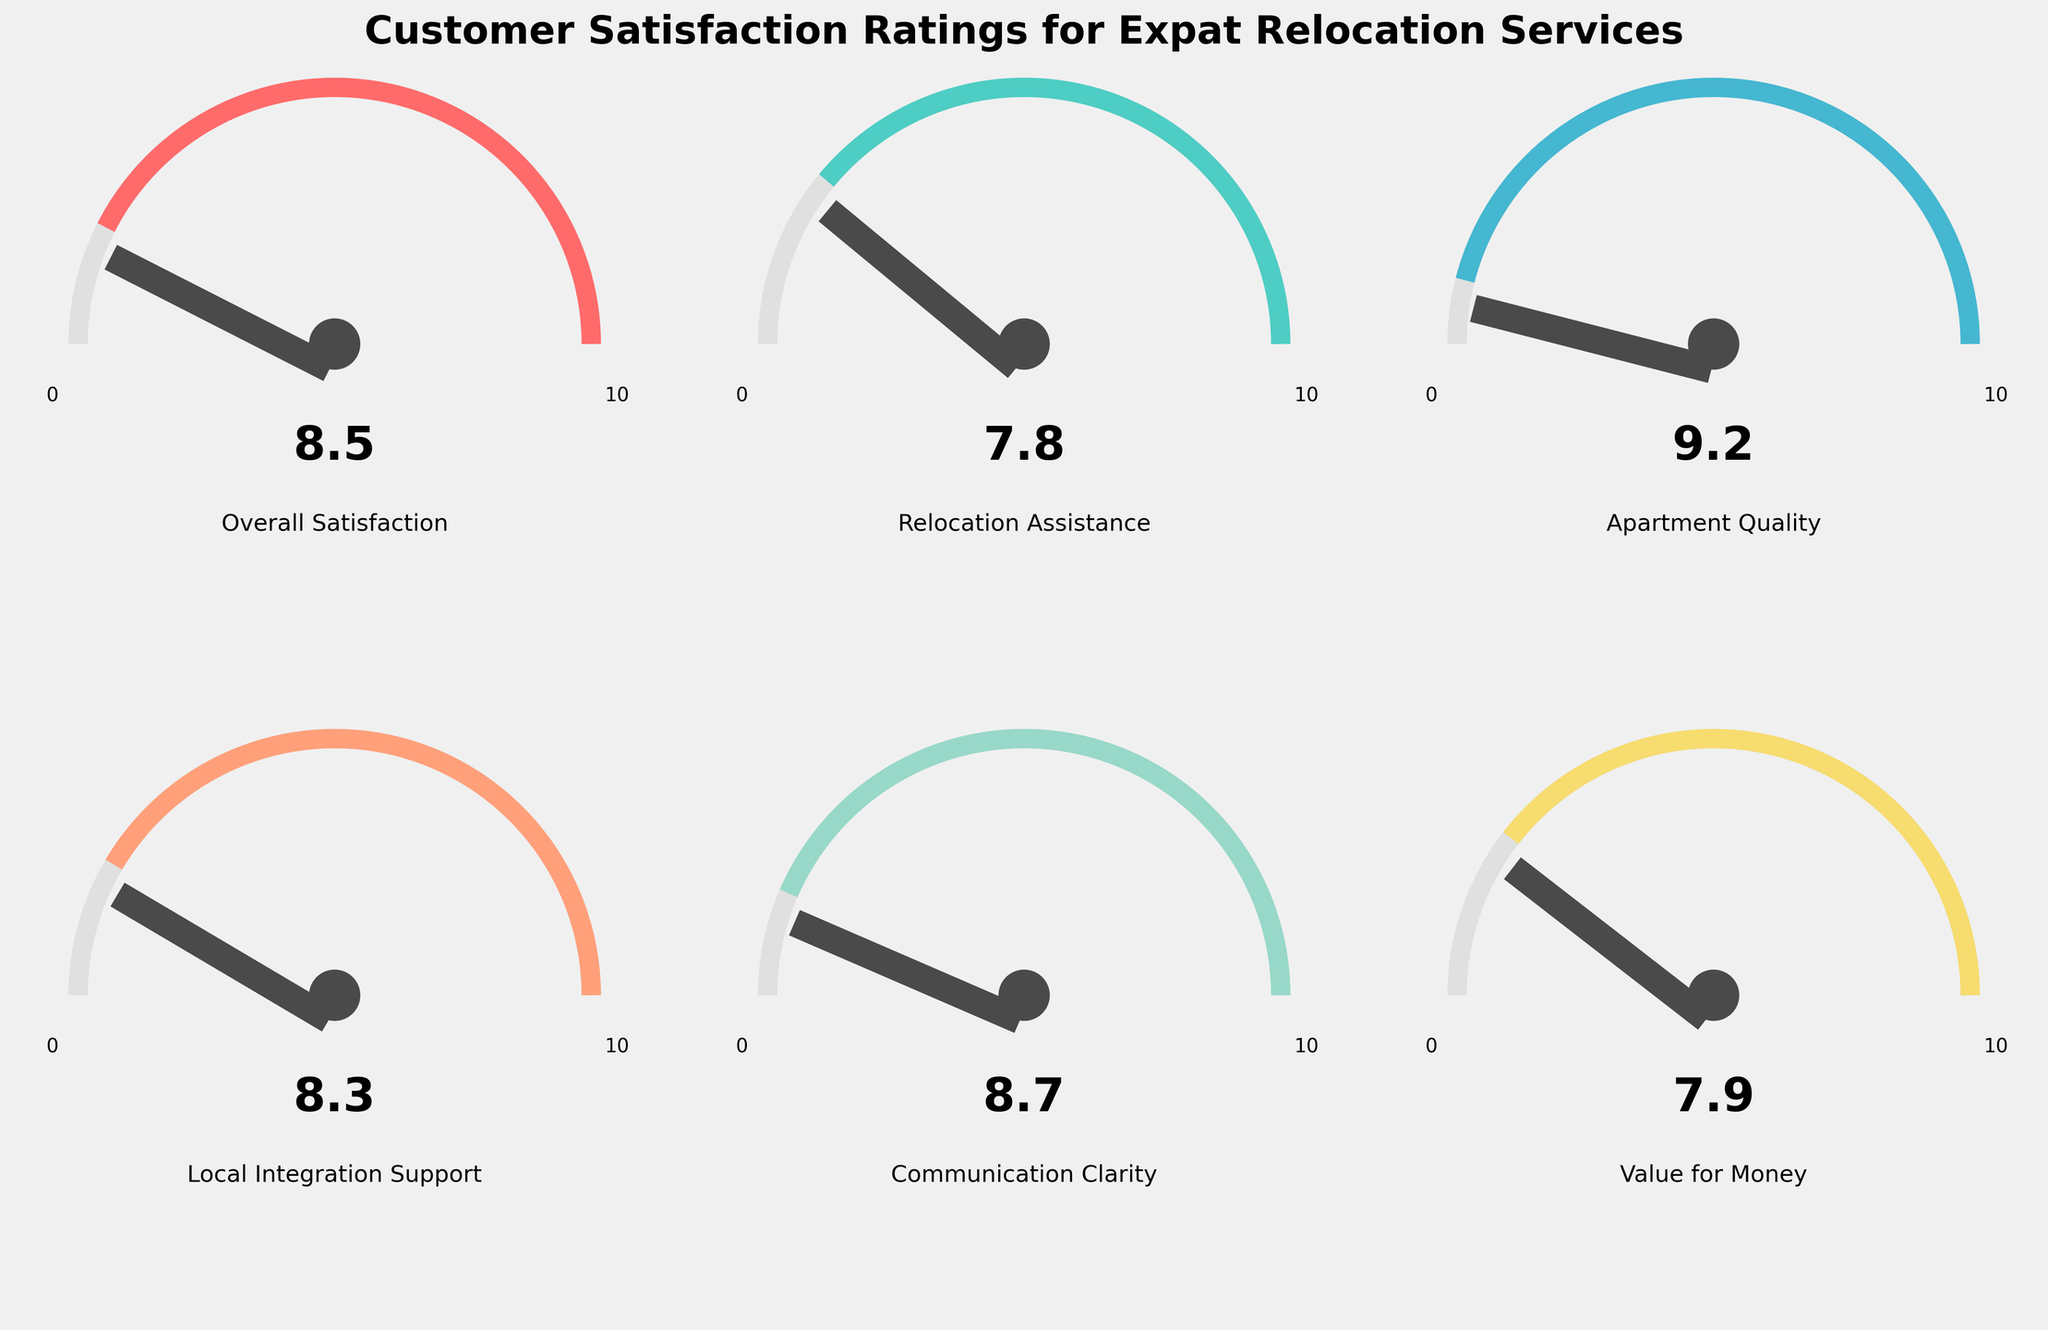What is the title of the chart? The title of the chart is located at the top of the figure, usually in a larger and bolder font. In this case, it reads "Customer Satisfaction Ratings for Expat Relocation Services".
Answer: Customer Satisfaction Ratings for Expat Relocation Services How many categories are shown in the figure? The figure consists of multiple gauges, each representing a different category. By counting these gauges, we can determine the total number of categories.
Answer: Six Which category has the highest satisfaction rating? To determine the highest rating, we compare the values indicated on each gauge. The one with the highest value is "Apartment Quality" with a value of 9.2.
Answer: Apartment Quality Compare the "Relocation Assistance" and "Value for Money" ratings. Which one is higher and by how much? "Relocation Assistance" has a rating of 7.8, and "Value for Money" has a rating of 7.9. By subtracting the two values, we see that "Value for Money" is higher by 0.1.
Answer: Value for Money by 0.1 Which category has the lowest satisfaction rating? By examining the ratings on each gauge, the category with the lowest rating is "Relocation Assistance," with a value of 7.8.
Answer: Relocation Assistance What is the average satisfaction rating across all categories? To find the average rating, sum all the values and divide by the number of categories: (8.5 + 7.8 + 9.2 + 8.3 + 8.7 + 7.9) / 6 = 50.4 / 6 ≈ 8.4.
Answer: 8.4 Is the "Communication Clarity" rating greater than the "Local Integration Support" rating? The "Communication Clarity" rating is 8.7, and the "Local Integration Support" rating is 8.3. Since 8.7 is greater than 8.3, the answer is yes.
Answer: Yes Is there any category with a perfect score of 10? To determine this, we check each gauge for the value of 10. None of the gauges show a rating of 10.
Answer: No Subtract the satisfaction rating of "Relocation Assistance" from "Local Integration Support". What is the result? The "Local Integration Support" rating is 8.3, and "Relocation Assistance" is 7.8. Subtracting these values: 8.3 - 7.8 = 0.5.
Answer: 0.5 What is the total sum of all the satisfaction ratings combined? Summing all the values: 8.5 + 7.8 + 9.2 + 8.3 + 8.7 + 7.9 = 50.4.
Answer: 50.4 